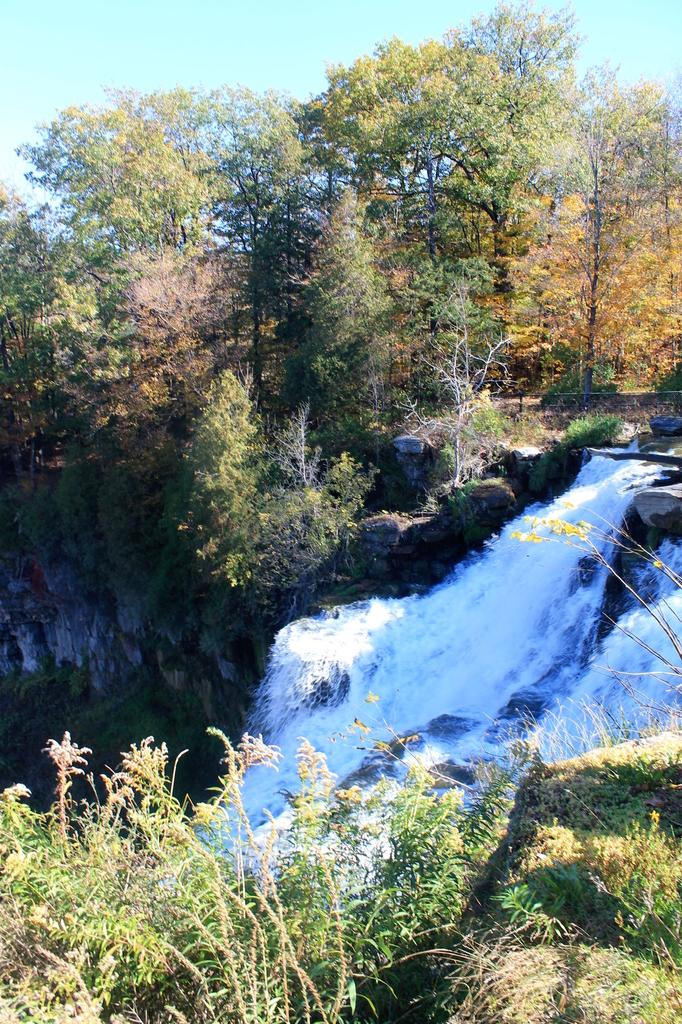What type of vegetation can be seen in the image? There are plants and trees in the image. What natural feature is present in the image? There is a waterfall in the image. What can be seen in the background of the image? The sky is visible in the background of the image. How would you describe the sky in the image? The sky appears to be clear in the image. What type of scent can be detected from the boy in the image? There is no boy present in the image, so it is not possible to determine any scent associated with him. 